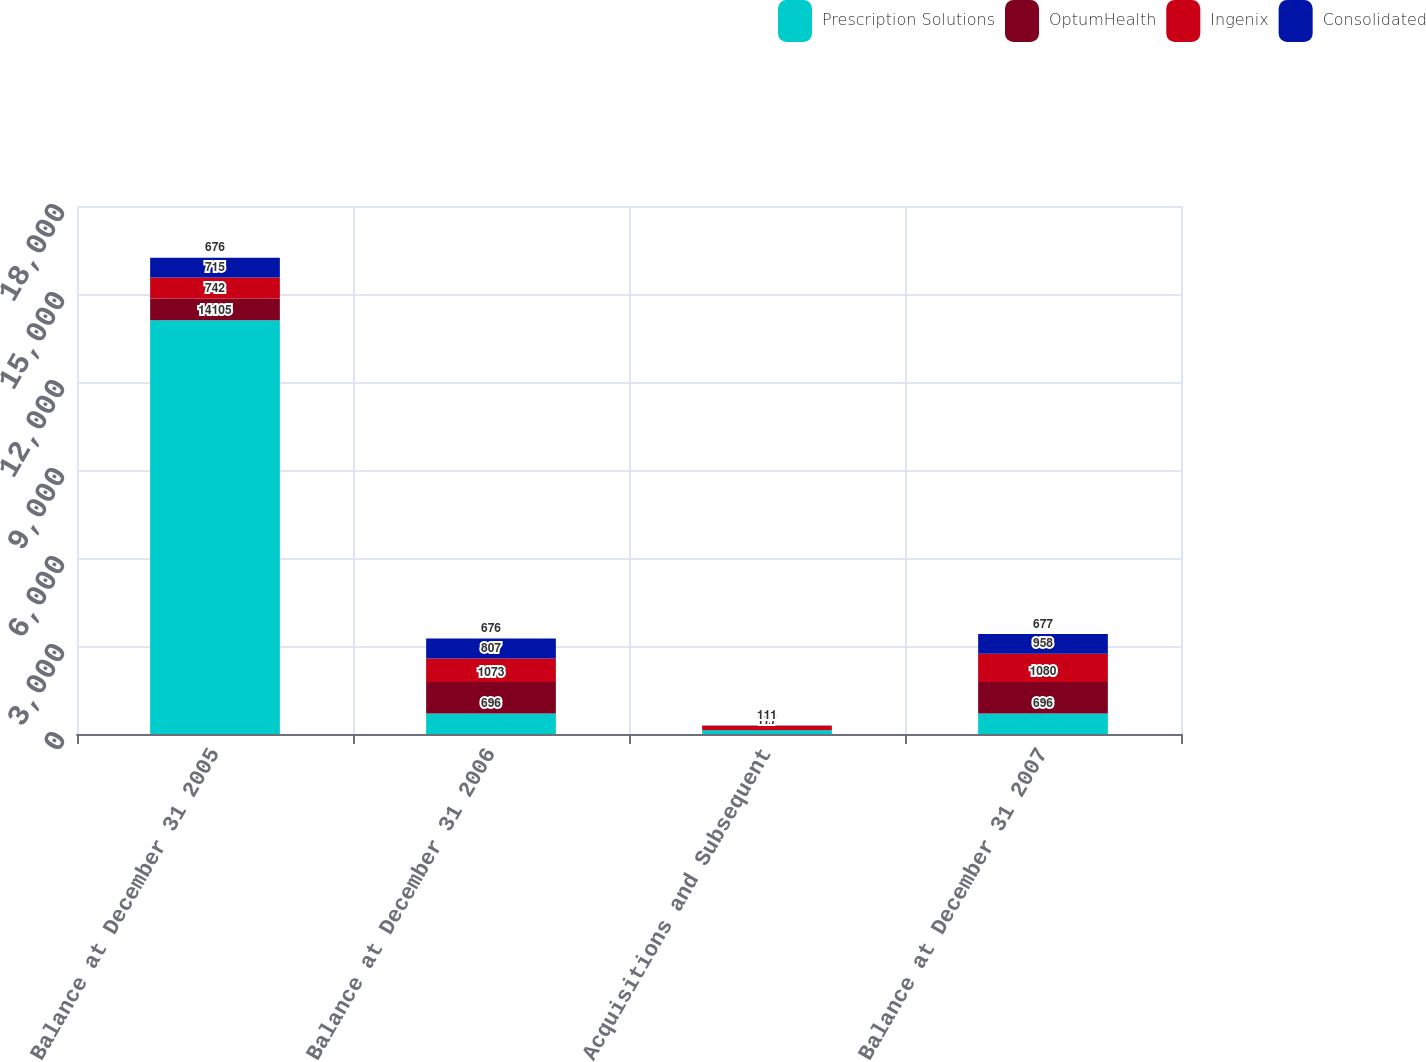<chart> <loc_0><loc_0><loc_500><loc_500><stacked_bar_chart><ecel><fcel>Balance at December 31 2005<fcel>Balance at December 31 2006<fcel>Acquisitions and Subsequent<fcel>Balance at December 31 2007<nl><fcel>Prescription Solutions<fcel>14105<fcel>696<fcel>127<fcel>696<nl><fcel>OptumHealth<fcel>742<fcel>1073<fcel>7<fcel>1080<nl><fcel>Ingenix<fcel>715<fcel>807<fcel>151<fcel>958<nl><fcel>Consolidated<fcel>676<fcel>676<fcel>1<fcel>677<nl></chart> 